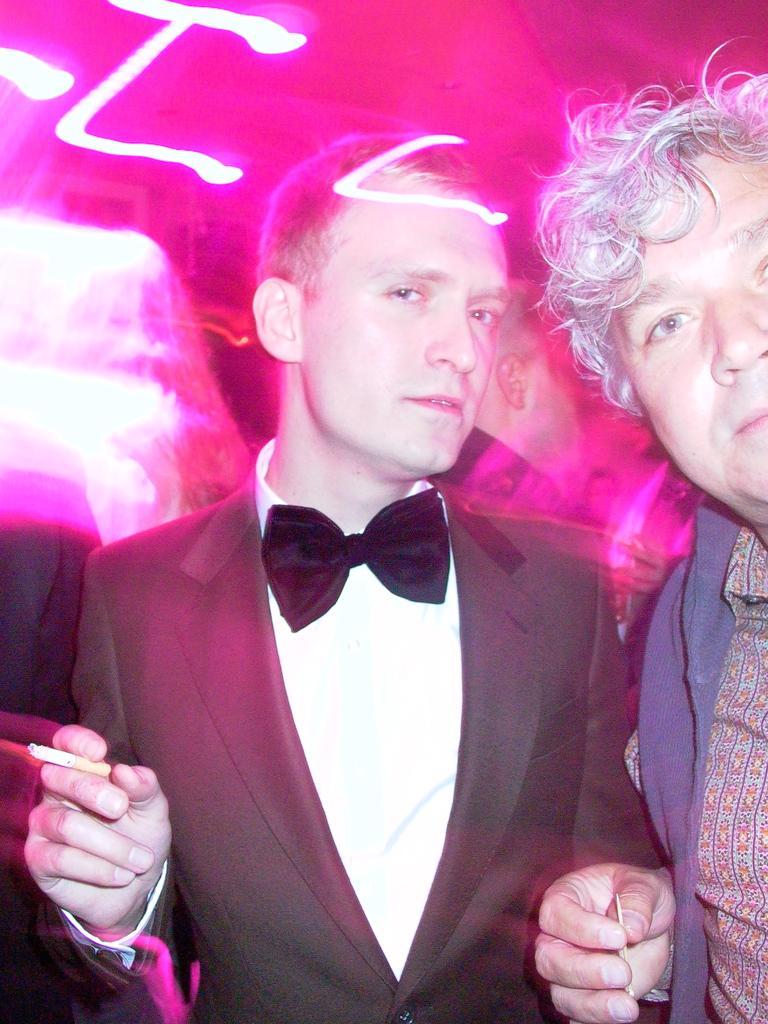Please provide a concise description of this image. In this image there are two persons looking at the camera, one of the person is holding a cigarette in his hand. 